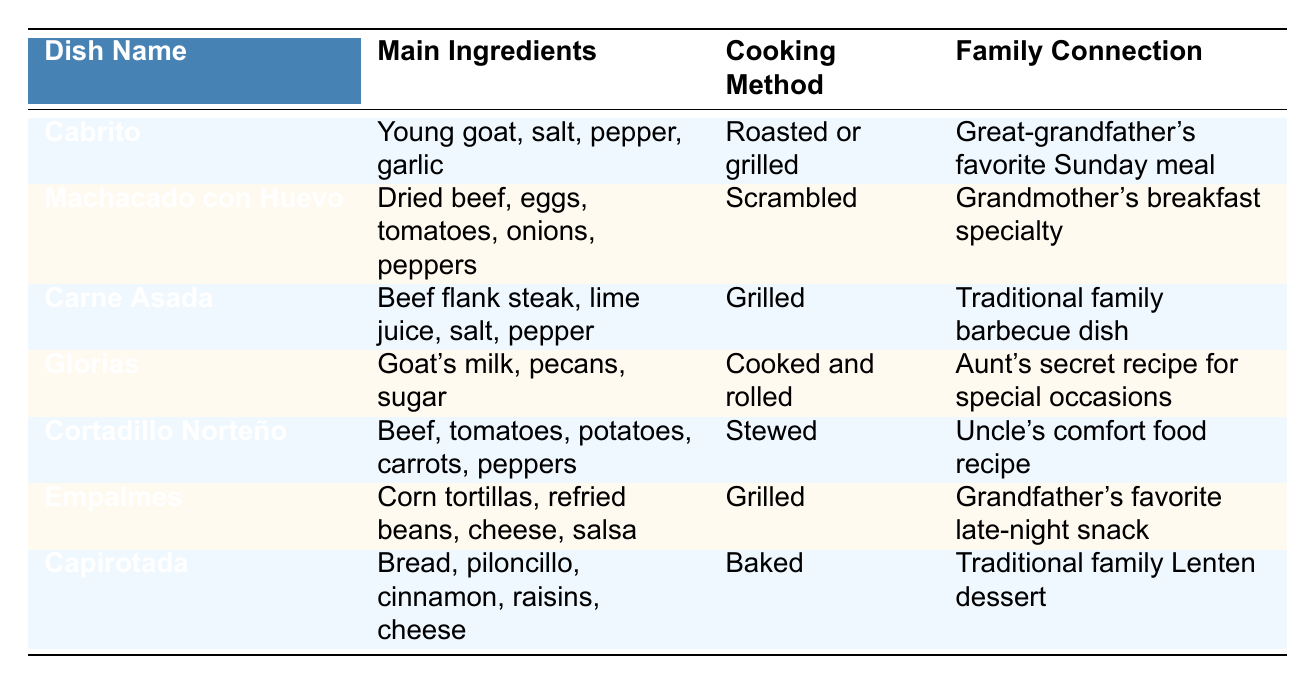What are the main ingredients of Cabrito? The table lists "Young goat, salt, pepper, garlic" as the main ingredients for Cabrito.
Answer: Young goat, salt, pepper, garlic Which dish is associated with your grandfather's favorite late-night snack? According to the table, "Empalmes" is described as the grandfather's favorite late-night snack.
Answer: Empalmes How many dishes are listed that involve grilling as the cooking method? The table shows two dishes with grilling as the cooking method, specifically Cabrito and Empalmes.
Answer: 2 Is Glorias made with cow's milk? The table indicates that Glorias is made with "Goat's milk," so the statement is false.
Answer: No Which dish has a family connection to the aunt's secret recipe? The table indicates that Glorias is connected to the aunt's secret recipe.
Answer: Glorias What is the cooking method for Machacado con Huevo? The table specifies the cooking method for Machacado con Huevo is "Scrambled."
Answer: Scrambled List all dishes that include beef as a main ingredient. The table shows that "Machacado con Huevo," "Carne Asada," and "Cortadillo Norteño" all include beef as a main ingredient.
Answer: Machacado con Huevo, Carne Asada, Cortadillo Norteño What is the only dessert mentioned in the table? The table identifies Capirotada as the only dessert among the listed dishes.
Answer: Capirotada How many dishes have a mention of a family connection? Each of the seven dishes in the table has a family connection mentioned, totaling seven.
Answer: 7 Which dish uses piloncillo as an ingredient? The table clearly lists piloncillo as an ingredient in Capirotada.
Answer: Capirotada 